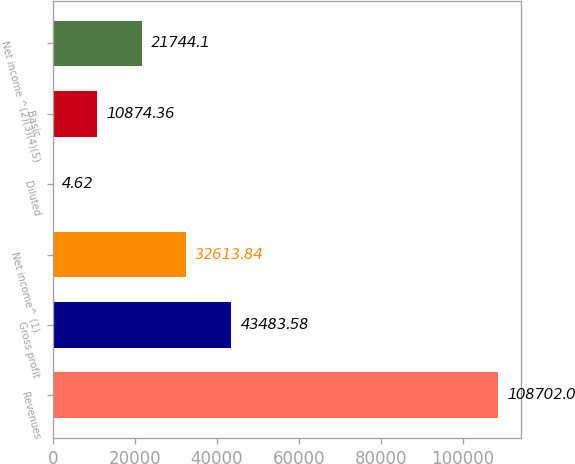Convert chart to OTSL. <chart><loc_0><loc_0><loc_500><loc_500><bar_chart><fcel>Revenues<fcel>Gross profit<fcel>Net income^ (1)<fcel>Diluted<fcel>Basic<fcel>Net income ^(2)(3)(4)(5)<nl><fcel>108702<fcel>43483.6<fcel>32613.8<fcel>4.62<fcel>10874.4<fcel>21744.1<nl></chart> 